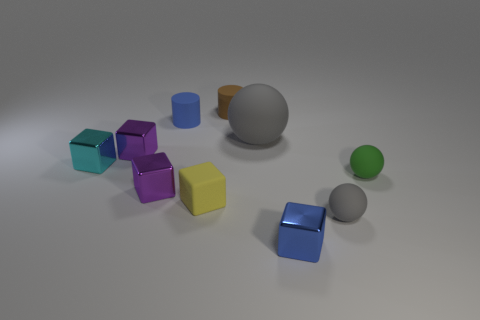There is a brown matte cylinder; does it have the same size as the gray sphere that is behind the small yellow cube?
Provide a succinct answer. No. There is a rubber cube that is in front of the rubber sphere that is on the left side of the tiny blue object that is on the right side of the small brown rubber cylinder; what size is it?
Your answer should be very brief. Small. Are there any big brown matte cylinders?
Provide a succinct answer. No. There is a small sphere that is the same color as the big rubber sphere; what is it made of?
Keep it short and to the point. Rubber. How many small objects are the same color as the big rubber sphere?
Your answer should be very brief. 1. What number of things are either rubber balls that are right of the tiny blue block or blocks that are in front of the tiny gray thing?
Your answer should be compact. 3. What number of things are to the left of the blue object behind the green rubber sphere?
Your answer should be compact. 3. What color is the small block that is the same material as the large object?
Offer a terse response. Yellow. Is there a matte thing of the same size as the green matte ball?
Your answer should be very brief. Yes. The blue shiny object that is the same size as the brown rubber cylinder is what shape?
Your answer should be very brief. Cube. 